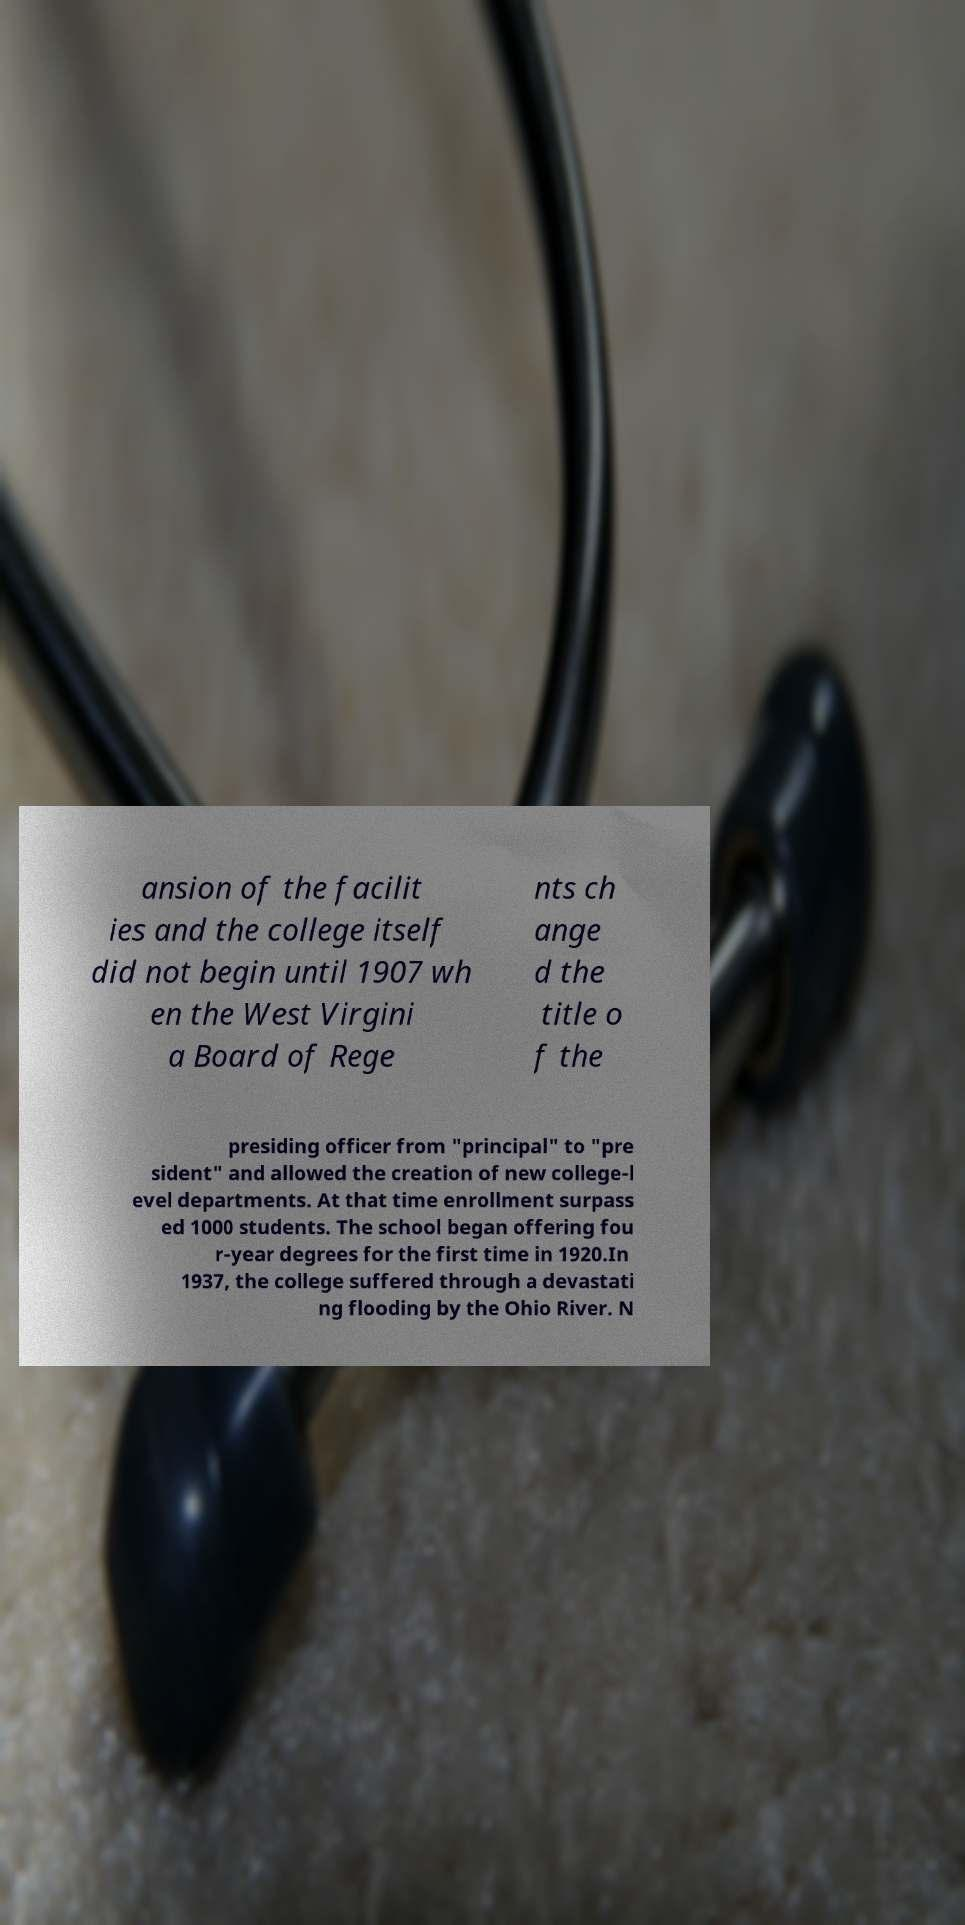Please identify and transcribe the text found in this image. ansion of the facilit ies and the college itself did not begin until 1907 wh en the West Virgini a Board of Rege nts ch ange d the title o f the presiding officer from "principal" to "pre sident" and allowed the creation of new college-l evel departments. At that time enrollment surpass ed 1000 students. The school began offering fou r-year degrees for the first time in 1920.In 1937, the college suffered through a devastati ng flooding by the Ohio River. N 